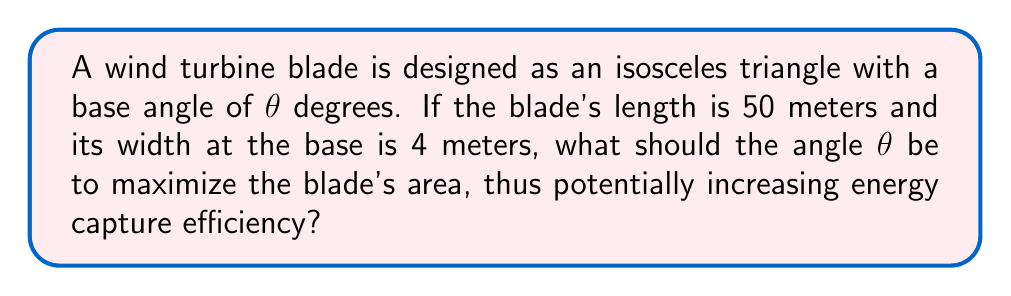Can you solve this math problem? Let's approach this step-by-step:

1) First, we need to express the area of the triangular blade in terms of $\theta$.

2) The area of a triangle is given by: $A = \frac{1}{2} \times base \times height$

3) We know the base is 4 meters. We need to find the height in terms of $\theta$.

4) In an isosceles triangle, the height bisects the base. So, we can split the triangle into two right triangles.

5) In one of these right triangles:
   $\sin(\theta) = \frac{2}{50} = \frac{1}{25}$

6) The height of the original triangle is:
   $h = 50 \cos(\theta)$

7) Now we can express the area in terms of $\theta$:
   $A = \frac{1}{2} \times 4 \times 50 \cos(\theta) = 100 \cos(\theta)$

8) To maximize this, we need to find where its derivative equals zero:
   $\frac{dA}{d\theta} = -100 \sin(\theta) = 0$

9) This occurs when $\sin(\theta) = 0$, which happens when $\theta = 0°$ or $180°$.

10) The second derivative is $-100 \cos(\theta)$, which is negative when $\theta = 0°$, confirming this is a maximum.

11) However, $\theta = 0°$ is not practical for a real turbine blade. We need to find $\theta$ when:
    $\sin(\theta) = \frac{1}{25}$

12) Taking the inverse sine:
    $\theta = \arcsin(\frac{1}{25}) \approx 2.29°$

This angle will provide the maximum practical area for the given dimensions.
Answer: $\theta \approx 2.29°$ 